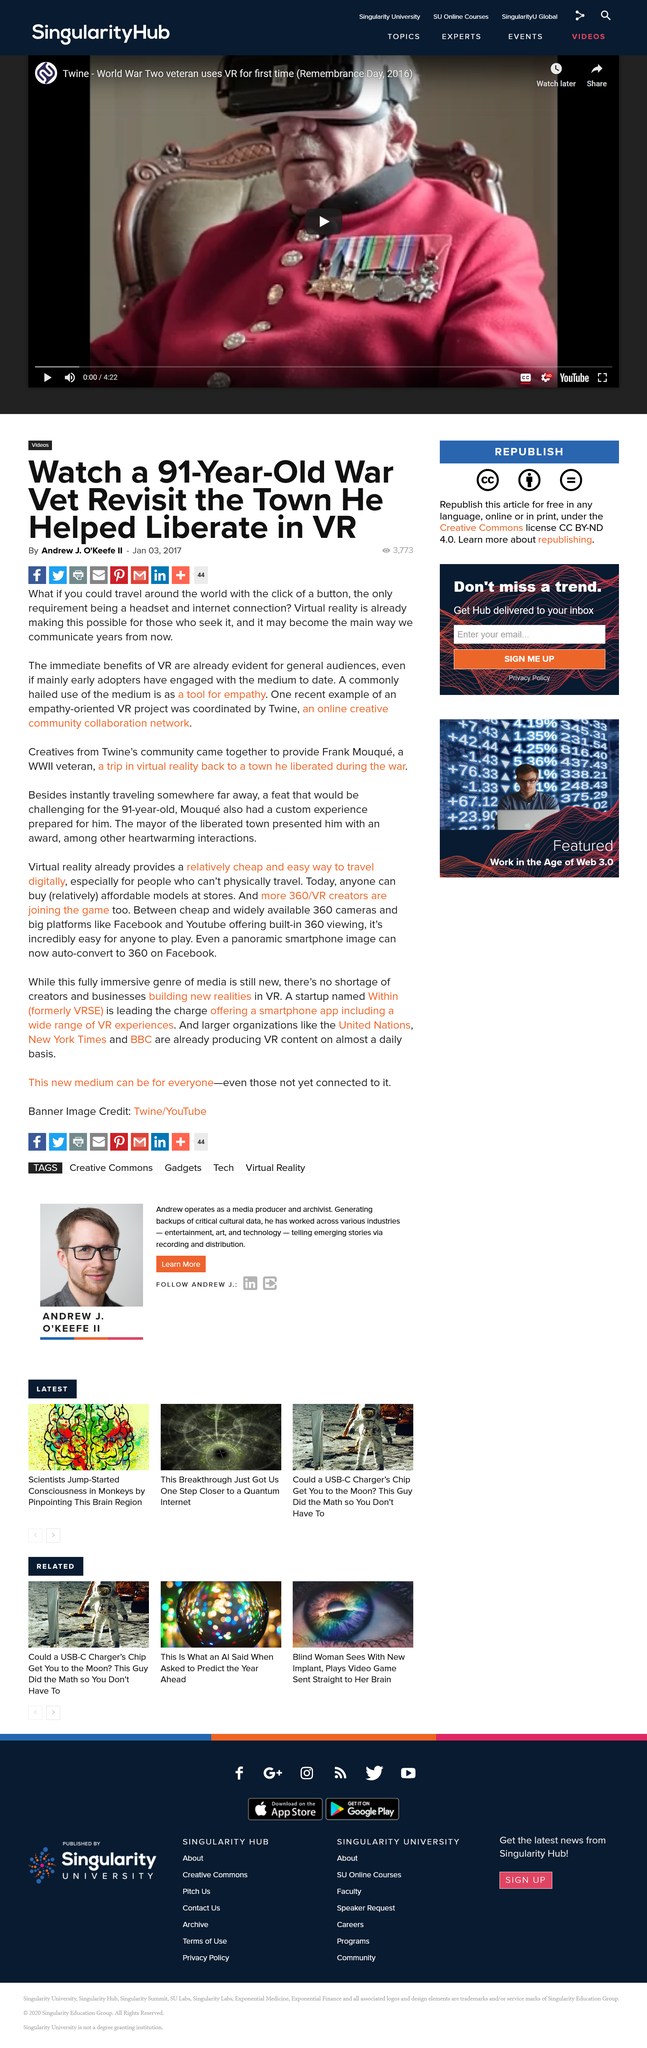List a handful of essential elements in this visual. Virtual reality has significantly impacted Frank Mouque's life by providing him with an immersive experience of visiting a town that he liberated during World War II. Twine is an online platform that enables creative communities to collaborate and network in a cohesive and effective manner. Virtual reality has the potential to revolutionize the way we communicate with one another in the future. It may become the primary means by which we interact and connect with each other, enabling us to transcend the limitations of time and space and forge deeply meaningful connections across the globe. 